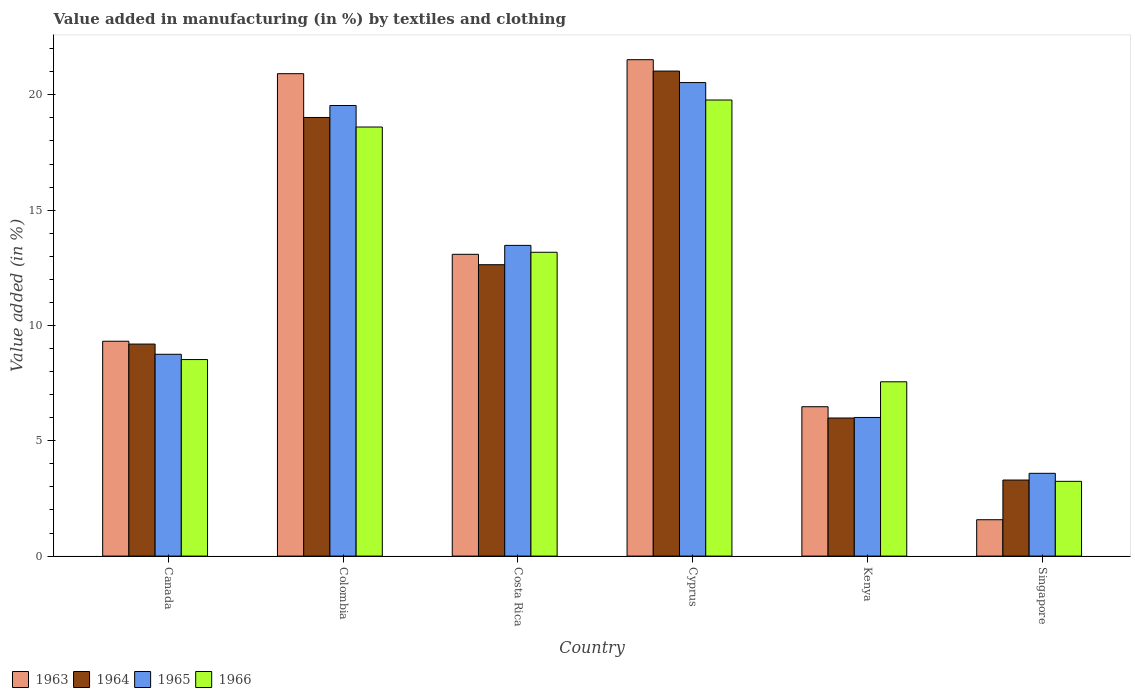How many different coloured bars are there?
Your response must be concise. 4. Are the number of bars per tick equal to the number of legend labels?
Offer a terse response. Yes. Are the number of bars on each tick of the X-axis equal?
Your answer should be compact. Yes. How many bars are there on the 3rd tick from the left?
Provide a short and direct response. 4. What is the label of the 5th group of bars from the left?
Your answer should be very brief. Kenya. What is the percentage of value added in manufacturing by textiles and clothing in 1966 in Canada?
Keep it short and to the point. 8.52. Across all countries, what is the maximum percentage of value added in manufacturing by textiles and clothing in 1965?
Your response must be concise. 20.53. Across all countries, what is the minimum percentage of value added in manufacturing by textiles and clothing in 1964?
Offer a very short reply. 3.3. In which country was the percentage of value added in manufacturing by textiles and clothing in 1965 maximum?
Your response must be concise. Cyprus. In which country was the percentage of value added in manufacturing by textiles and clothing in 1964 minimum?
Your answer should be very brief. Singapore. What is the total percentage of value added in manufacturing by textiles and clothing in 1966 in the graph?
Your answer should be very brief. 70.87. What is the difference between the percentage of value added in manufacturing by textiles and clothing in 1963 in Colombia and that in Singapore?
Your answer should be very brief. 19.34. What is the difference between the percentage of value added in manufacturing by textiles and clothing in 1965 in Canada and the percentage of value added in manufacturing by textiles and clothing in 1964 in Colombia?
Keep it short and to the point. -10.27. What is the average percentage of value added in manufacturing by textiles and clothing in 1963 per country?
Your response must be concise. 12.15. What is the difference between the percentage of value added in manufacturing by textiles and clothing of/in 1963 and percentage of value added in manufacturing by textiles and clothing of/in 1966 in Colombia?
Provide a succinct answer. 2.31. What is the ratio of the percentage of value added in manufacturing by textiles and clothing in 1965 in Costa Rica to that in Kenya?
Make the answer very short. 2.24. Is the difference between the percentage of value added in manufacturing by textiles and clothing in 1963 in Cyprus and Singapore greater than the difference between the percentage of value added in manufacturing by textiles and clothing in 1966 in Cyprus and Singapore?
Your response must be concise. Yes. What is the difference between the highest and the second highest percentage of value added in manufacturing by textiles and clothing in 1963?
Provide a succinct answer. -7.83. What is the difference between the highest and the lowest percentage of value added in manufacturing by textiles and clothing in 1964?
Make the answer very short. 17.73. In how many countries, is the percentage of value added in manufacturing by textiles and clothing in 1966 greater than the average percentage of value added in manufacturing by textiles and clothing in 1966 taken over all countries?
Provide a succinct answer. 3. Is it the case that in every country, the sum of the percentage of value added in manufacturing by textiles and clothing in 1963 and percentage of value added in manufacturing by textiles and clothing in 1964 is greater than the sum of percentage of value added in manufacturing by textiles and clothing in 1966 and percentage of value added in manufacturing by textiles and clothing in 1965?
Provide a succinct answer. No. What does the 4th bar from the left in Kenya represents?
Offer a very short reply. 1966. How many bars are there?
Provide a short and direct response. 24. What is the difference between two consecutive major ticks on the Y-axis?
Keep it short and to the point. 5. Does the graph contain grids?
Your response must be concise. No. What is the title of the graph?
Your answer should be compact. Value added in manufacturing (in %) by textiles and clothing. Does "1984" appear as one of the legend labels in the graph?
Your answer should be very brief. No. What is the label or title of the X-axis?
Your response must be concise. Country. What is the label or title of the Y-axis?
Provide a short and direct response. Value added (in %). What is the Value added (in %) of 1963 in Canada?
Give a very brief answer. 9.32. What is the Value added (in %) of 1964 in Canada?
Provide a short and direct response. 9.19. What is the Value added (in %) in 1965 in Canada?
Offer a very short reply. 8.75. What is the Value added (in %) in 1966 in Canada?
Your answer should be very brief. 8.52. What is the Value added (in %) in 1963 in Colombia?
Provide a short and direct response. 20.92. What is the Value added (in %) in 1964 in Colombia?
Your response must be concise. 19.02. What is the Value added (in %) of 1965 in Colombia?
Your answer should be compact. 19.54. What is the Value added (in %) of 1966 in Colombia?
Your answer should be compact. 18.6. What is the Value added (in %) of 1963 in Costa Rica?
Keep it short and to the point. 13.08. What is the Value added (in %) in 1964 in Costa Rica?
Provide a succinct answer. 12.63. What is the Value added (in %) in 1965 in Costa Rica?
Your response must be concise. 13.47. What is the Value added (in %) of 1966 in Costa Rica?
Your response must be concise. 13.17. What is the Value added (in %) in 1963 in Cyprus?
Make the answer very short. 21.52. What is the Value added (in %) in 1964 in Cyprus?
Your answer should be very brief. 21.03. What is the Value added (in %) of 1965 in Cyprus?
Offer a very short reply. 20.53. What is the Value added (in %) in 1966 in Cyprus?
Provide a short and direct response. 19.78. What is the Value added (in %) of 1963 in Kenya?
Provide a succinct answer. 6.48. What is the Value added (in %) of 1964 in Kenya?
Your answer should be very brief. 5.99. What is the Value added (in %) of 1965 in Kenya?
Give a very brief answer. 6.01. What is the Value added (in %) of 1966 in Kenya?
Provide a short and direct response. 7.56. What is the Value added (in %) of 1963 in Singapore?
Give a very brief answer. 1.58. What is the Value added (in %) in 1964 in Singapore?
Your response must be concise. 3.3. What is the Value added (in %) in 1965 in Singapore?
Make the answer very short. 3.59. What is the Value added (in %) in 1966 in Singapore?
Provide a succinct answer. 3.24. Across all countries, what is the maximum Value added (in %) in 1963?
Provide a succinct answer. 21.52. Across all countries, what is the maximum Value added (in %) in 1964?
Offer a terse response. 21.03. Across all countries, what is the maximum Value added (in %) of 1965?
Provide a short and direct response. 20.53. Across all countries, what is the maximum Value added (in %) in 1966?
Provide a short and direct response. 19.78. Across all countries, what is the minimum Value added (in %) of 1963?
Your answer should be very brief. 1.58. Across all countries, what is the minimum Value added (in %) in 1964?
Your answer should be compact. 3.3. Across all countries, what is the minimum Value added (in %) of 1965?
Offer a terse response. 3.59. Across all countries, what is the minimum Value added (in %) in 1966?
Your response must be concise. 3.24. What is the total Value added (in %) of 1963 in the graph?
Provide a short and direct response. 72.9. What is the total Value added (in %) in 1964 in the graph?
Your response must be concise. 71.16. What is the total Value added (in %) of 1965 in the graph?
Provide a succinct answer. 71.89. What is the total Value added (in %) in 1966 in the graph?
Make the answer very short. 70.87. What is the difference between the Value added (in %) in 1963 in Canada and that in Colombia?
Provide a succinct answer. -11.6. What is the difference between the Value added (in %) of 1964 in Canada and that in Colombia?
Provide a short and direct response. -9.82. What is the difference between the Value added (in %) in 1965 in Canada and that in Colombia?
Offer a terse response. -10.79. What is the difference between the Value added (in %) of 1966 in Canada and that in Colombia?
Your response must be concise. -10.08. What is the difference between the Value added (in %) in 1963 in Canada and that in Costa Rica?
Provide a succinct answer. -3.77. What is the difference between the Value added (in %) in 1964 in Canada and that in Costa Rica?
Keep it short and to the point. -3.44. What is the difference between the Value added (in %) in 1965 in Canada and that in Costa Rica?
Your response must be concise. -4.72. What is the difference between the Value added (in %) of 1966 in Canada and that in Costa Rica?
Provide a short and direct response. -4.65. What is the difference between the Value added (in %) in 1963 in Canada and that in Cyprus?
Offer a very short reply. -12.21. What is the difference between the Value added (in %) in 1964 in Canada and that in Cyprus?
Give a very brief answer. -11.84. What is the difference between the Value added (in %) of 1965 in Canada and that in Cyprus?
Ensure brevity in your answer.  -11.78. What is the difference between the Value added (in %) of 1966 in Canada and that in Cyprus?
Your answer should be very brief. -11.25. What is the difference between the Value added (in %) of 1963 in Canada and that in Kenya?
Offer a terse response. 2.84. What is the difference between the Value added (in %) in 1964 in Canada and that in Kenya?
Provide a short and direct response. 3.21. What is the difference between the Value added (in %) in 1965 in Canada and that in Kenya?
Give a very brief answer. 2.74. What is the difference between the Value added (in %) of 1966 in Canada and that in Kenya?
Make the answer very short. 0.96. What is the difference between the Value added (in %) in 1963 in Canada and that in Singapore?
Provide a succinct answer. 7.74. What is the difference between the Value added (in %) of 1964 in Canada and that in Singapore?
Your answer should be very brief. 5.9. What is the difference between the Value added (in %) in 1965 in Canada and that in Singapore?
Your answer should be very brief. 5.16. What is the difference between the Value added (in %) in 1966 in Canada and that in Singapore?
Provide a short and direct response. 5.28. What is the difference between the Value added (in %) in 1963 in Colombia and that in Costa Rica?
Your answer should be compact. 7.83. What is the difference between the Value added (in %) in 1964 in Colombia and that in Costa Rica?
Provide a succinct answer. 6.38. What is the difference between the Value added (in %) of 1965 in Colombia and that in Costa Rica?
Your answer should be compact. 6.06. What is the difference between the Value added (in %) of 1966 in Colombia and that in Costa Rica?
Provide a short and direct response. 5.43. What is the difference between the Value added (in %) of 1963 in Colombia and that in Cyprus?
Keep it short and to the point. -0.61. What is the difference between the Value added (in %) in 1964 in Colombia and that in Cyprus?
Give a very brief answer. -2.01. What is the difference between the Value added (in %) in 1965 in Colombia and that in Cyprus?
Offer a very short reply. -0.99. What is the difference between the Value added (in %) of 1966 in Colombia and that in Cyprus?
Your answer should be very brief. -1.17. What is the difference between the Value added (in %) of 1963 in Colombia and that in Kenya?
Keep it short and to the point. 14.44. What is the difference between the Value added (in %) of 1964 in Colombia and that in Kenya?
Ensure brevity in your answer.  13.03. What is the difference between the Value added (in %) in 1965 in Colombia and that in Kenya?
Your response must be concise. 13.53. What is the difference between the Value added (in %) in 1966 in Colombia and that in Kenya?
Your answer should be very brief. 11.05. What is the difference between the Value added (in %) of 1963 in Colombia and that in Singapore?
Your answer should be very brief. 19.34. What is the difference between the Value added (in %) of 1964 in Colombia and that in Singapore?
Your answer should be compact. 15.72. What is the difference between the Value added (in %) of 1965 in Colombia and that in Singapore?
Your response must be concise. 15.95. What is the difference between the Value added (in %) in 1966 in Colombia and that in Singapore?
Give a very brief answer. 15.36. What is the difference between the Value added (in %) in 1963 in Costa Rica and that in Cyprus?
Keep it short and to the point. -8.44. What is the difference between the Value added (in %) of 1964 in Costa Rica and that in Cyprus?
Keep it short and to the point. -8.4. What is the difference between the Value added (in %) of 1965 in Costa Rica and that in Cyprus?
Give a very brief answer. -7.06. What is the difference between the Value added (in %) in 1966 in Costa Rica and that in Cyprus?
Provide a short and direct response. -6.6. What is the difference between the Value added (in %) of 1963 in Costa Rica and that in Kenya?
Your answer should be compact. 6.61. What is the difference between the Value added (in %) in 1964 in Costa Rica and that in Kenya?
Give a very brief answer. 6.65. What is the difference between the Value added (in %) in 1965 in Costa Rica and that in Kenya?
Offer a very short reply. 7.46. What is the difference between the Value added (in %) in 1966 in Costa Rica and that in Kenya?
Provide a short and direct response. 5.62. What is the difference between the Value added (in %) in 1963 in Costa Rica and that in Singapore?
Keep it short and to the point. 11.51. What is the difference between the Value added (in %) of 1964 in Costa Rica and that in Singapore?
Your answer should be compact. 9.34. What is the difference between the Value added (in %) of 1965 in Costa Rica and that in Singapore?
Ensure brevity in your answer.  9.88. What is the difference between the Value added (in %) of 1966 in Costa Rica and that in Singapore?
Provide a succinct answer. 9.93. What is the difference between the Value added (in %) in 1963 in Cyprus and that in Kenya?
Provide a short and direct response. 15.05. What is the difference between the Value added (in %) in 1964 in Cyprus and that in Kenya?
Provide a succinct answer. 15.04. What is the difference between the Value added (in %) in 1965 in Cyprus and that in Kenya?
Provide a short and direct response. 14.52. What is the difference between the Value added (in %) in 1966 in Cyprus and that in Kenya?
Provide a short and direct response. 12.22. What is the difference between the Value added (in %) of 1963 in Cyprus and that in Singapore?
Your answer should be very brief. 19.95. What is the difference between the Value added (in %) of 1964 in Cyprus and that in Singapore?
Make the answer very short. 17.73. What is the difference between the Value added (in %) of 1965 in Cyprus and that in Singapore?
Offer a terse response. 16.94. What is the difference between the Value added (in %) of 1966 in Cyprus and that in Singapore?
Offer a terse response. 16.53. What is the difference between the Value added (in %) of 1963 in Kenya and that in Singapore?
Your answer should be compact. 4.9. What is the difference between the Value added (in %) of 1964 in Kenya and that in Singapore?
Offer a terse response. 2.69. What is the difference between the Value added (in %) of 1965 in Kenya and that in Singapore?
Your answer should be compact. 2.42. What is the difference between the Value added (in %) of 1966 in Kenya and that in Singapore?
Give a very brief answer. 4.32. What is the difference between the Value added (in %) of 1963 in Canada and the Value added (in %) of 1964 in Colombia?
Ensure brevity in your answer.  -9.7. What is the difference between the Value added (in %) of 1963 in Canada and the Value added (in %) of 1965 in Colombia?
Offer a terse response. -10.22. What is the difference between the Value added (in %) of 1963 in Canada and the Value added (in %) of 1966 in Colombia?
Your response must be concise. -9.29. What is the difference between the Value added (in %) of 1964 in Canada and the Value added (in %) of 1965 in Colombia?
Offer a very short reply. -10.34. What is the difference between the Value added (in %) of 1964 in Canada and the Value added (in %) of 1966 in Colombia?
Provide a short and direct response. -9.41. What is the difference between the Value added (in %) in 1965 in Canada and the Value added (in %) in 1966 in Colombia?
Your response must be concise. -9.85. What is the difference between the Value added (in %) of 1963 in Canada and the Value added (in %) of 1964 in Costa Rica?
Make the answer very short. -3.32. What is the difference between the Value added (in %) in 1963 in Canada and the Value added (in %) in 1965 in Costa Rica?
Keep it short and to the point. -4.16. What is the difference between the Value added (in %) in 1963 in Canada and the Value added (in %) in 1966 in Costa Rica?
Make the answer very short. -3.86. What is the difference between the Value added (in %) in 1964 in Canada and the Value added (in %) in 1965 in Costa Rica?
Your answer should be very brief. -4.28. What is the difference between the Value added (in %) of 1964 in Canada and the Value added (in %) of 1966 in Costa Rica?
Ensure brevity in your answer.  -3.98. What is the difference between the Value added (in %) of 1965 in Canada and the Value added (in %) of 1966 in Costa Rica?
Provide a succinct answer. -4.42. What is the difference between the Value added (in %) of 1963 in Canada and the Value added (in %) of 1964 in Cyprus?
Your response must be concise. -11.71. What is the difference between the Value added (in %) in 1963 in Canada and the Value added (in %) in 1965 in Cyprus?
Offer a terse response. -11.21. What is the difference between the Value added (in %) of 1963 in Canada and the Value added (in %) of 1966 in Cyprus?
Give a very brief answer. -10.46. What is the difference between the Value added (in %) in 1964 in Canada and the Value added (in %) in 1965 in Cyprus?
Offer a terse response. -11.34. What is the difference between the Value added (in %) in 1964 in Canada and the Value added (in %) in 1966 in Cyprus?
Offer a terse response. -10.58. What is the difference between the Value added (in %) in 1965 in Canada and the Value added (in %) in 1966 in Cyprus?
Your answer should be very brief. -11.02. What is the difference between the Value added (in %) of 1963 in Canada and the Value added (in %) of 1964 in Kenya?
Give a very brief answer. 3.33. What is the difference between the Value added (in %) in 1963 in Canada and the Value added (in %) in 1965 in Kenya?
Offer a terse response. 3.31. What is the difference between the Value added (in %) in 1963 in Canada and the Value added (in %) in 1966 in Kenya?
Your response must be concise. 1.76. What is the difference between the Value added (in %) in 1964 in Canada and the Value added (in %) in 1965 in Kenya?
Ensure brevity in your answer.  3.18. What is the difference between the Value added (in %) of 1964 in Canada and the Value added (in %) of 1966 in Kenya?
Your answer should be very brief. 1.64. What is the difference between the Value added (in %) in 1965 in Canada and the Value added (in %) in 1966 in Kenya?
Make the answer very short. 1.19. What is the difference between the Value added (in %) in 1963 in Canada and the Value added (in %) in 1964 in Singapore?
Provide a short and direct response. 6.02. What is the difference between the Value added (in %) of 1963 in Canada and the Value added (in %) of 1965 in Singapore?
Your answer should be compact. 5.73. What is the difference between the Value added (in %) of 1963 in Canada and the Value added (in %) of 1966 in Singapore?
Make the answer very short. 6.08. What is the difference between the Value added (in %) of 1964 in Canada and the Value added (in %) of 1965 in Singapore?
Give a very brief answer. 5.6. What is the difference between the Value added (in %) in 1964 in Canada and the Value added (in %) in 1966 in Singapore?
Offer a terse response. 5.95. What is the difference between the Value added (in %) of 1965 in Canada and the Value added (in %) of 1966 in Singapore?
Give a very brief answer. 5.51. What is the difference between the Value added (in %) in 1963 in Colombia and the Value added (in %) in 1964 in Costa Rica?
Provide a succinct answer. 8.28. What is the difference between the Value added (in %) in 1963 in Colombia and the Value added (in %) in 1965 in Costa Rica?
Offer a terse response. 7.44. What is the difference between the Value added (in %) in 1963 in Colombia and the Value added (in %) in 1966 in Costa Rica?
Your answer should be compact. 7.74. What is the difference between the Value added (in %) in 1964 in Colombia and the Value added (in %) in 1965 in Costa Rica?
Your response must be concise. 5.55. What is the difference between the Value added (in %) of 1964 in Colombia and the Value added (in %) of 1966 in Costa Rica?
Your response must be concise. 5.84. What is the difference between the Value added (in %) of 1965 in Colombia and the Value added (in %) of 1966 in Costa Rica?
Provide a short and direct response. 6.36. What is the difference between the Value added (in %) in 1963 in Colombia and the Value added (in %) in 1964 in Cyprus?
Your response must be concise. -0.11. What is the difference between the Value added (in %) in 1963 in Colombia and the Value added (in %) in 1965 in Cyprus?
Offer a very short reply. 0.39. What is the difference between the Value added (in %) in 1963 in Colombia and the Value added (in %) in 1966 in Cyprus?
Provide a succinct answer. 1.14. What is the difference between the Value added (in %) of 1964 in Colombia and the Value added (in %) of 1965 in Cyprus?
Provide a succinct answer. -1.51. What is the difference between the Value added (in %) of 1964 in Colombia and the Value added (in %) of 1966 in Cyprus?
Provide a succinct answer. -0.76. What is the difference between the Value added (in %) in 1965 in Colombia and the Value added (in %) in 1966 in Cyprus?
Give a very brief answer. -0.24. What is the difference between the Value added (in %) in 1963 in Colombia and the Value added (in %) in 1964 in Kenya?
Your answer should be very brief. 14.93. What is the difference between the Value added (in %) in 1963 in Colombia and the Value added (in %) in 1965 in Kenya?
Ensure brevity in your answer.  14.91. What is the difference between the Value added (in %) in 1963 in Colombia and the Value added (in %) in 1966 in Kenya?
Your response must be concise. 13.36. What is the difference between the Value added (in %) in 1964 in Colombia and the Value added (in %) in 1965 in Kenya?
Give a very brief answer. 13.01. What is the difference between the Value added (in %) in 1964 in Colombia and the Value added (in %) in 1966 in Kenya?
Provide a succinct answer. 11.46. What is the difference between the Value added (in %) of 1965 in Colombia and the Value added (in %) of 1966 in Kenya?
Provide a short and direct response. 11.98. What is the difference between the Value added (in %) of 1963 in Colombia and the Value added (in %) of 1964 in Singapore?
Offer a terse response. 17.62. What is the difference between the Value added (in %) in 1963 in Colombia and the Value added (in %) in 1965 in Singapore?
Offer a terse response. 17.33. What is the difference between the Value added (in %) in 1963 in Colombia and the Value added (in %) in 1966 in Singapore?
Offer a very short reply. 17.68. What is the difference between the Value added (in %) of 1964 in Colombia and the Value added (in %) of 1965 in Singapore?
Ensure brevity in your answer.  15.43. What is the difference between the Value added (in %) in 1964 in Colombia and the Value added (in %) in 1966 in Singapore?
Provide a succinct answer. 15.78. What is the difference between the Value added (in %) in 1965 in Colombia and the Value added (in %) in 1966 in Singapore?
Provide a short and direct response. 16.3. What is the difference between the Value added (in %) in 1963 in Costa Rica and the Value added (in %) in 1964 in Cyprus?
Offer a very short reply. -7.95. What is the difference between the Value added (in %) of 1963 in Costa Rica and the Value added (in %) of 1965 in Cyprus?
Provide a short and direct response. -7.45. What is the difference between the Value added (in %) in 1963 in Costa Rica and the Value added (in %) in 1966 in Cyprus?
Your answer should be very brief. -6.69. What is the difference between the Value added (in %) of 1964 in Costa Rica and the Value added (in %) of 1965 in Cyprus?
Ensure brevity in your answer.  -7.9. What is the difference between the Value added (in %) of 1964 in Costa Rica and the Value added (in %) of 1966 in Cyprus?
Ensure brevity in your answer.  -7.14. What is the difference between the Value added (in %) in 1965 in Costa Rica and the Value added (in %) in 1966 in Cyprus?
Give a very brief answer. -6.3. What is the difference between the Value added (in %) in 1963 in Costa Rica and the Value added (in %) in 1964 in Kenya?
Provide a short and direct response. 7.1. What is the difference between the Value added (in %) in 1963 in Costa Rica and the Value added (in %) in 1965 in Kenya?
Make the answer very short. 7.07. What is the difference between the Value added (in %) of 1963 in Costa Rica and the Value added (in %) of 1966 in Kenya?
Keep it short and to the point. 5.53. What is the difference between the Value added (in %) in 1964 in Costa Rica and the Value added (in %) in 1965 in Kenya?
Provide a short and direct response. 6.62. What is the difference between the Value added (in %) in 1964 in Costa Rica and the Value added (in %) in 1966 in Kenya?
Your answer should be very brief. 5.08. What is the difference between the Value added (in %) in 1965 in Costa Rica and the Value added (in %) in 1966 in Kenya?
Your response must be concise. 5.91. What is the difference between the Value added (in %) in 1963 in Costa Rica and the Value added (in %) in 1964 in Singapore?
Make the answer very short. 9.79. What is the difference between the Value added (in %) of 1963 in Costa Rica and the Value added (in %) of 1965 in Singapore?
Your answer should be very brief. 9.5. What is the difference between the Value added (in %) of 1963 in Costa Rica and the Value added (in %) of 1966 in Singapore?
Make the answer very short. 9.84. What is the difference between the Value added (in %) in 1964 in Costa Rica and the Value added (in %) in 1965 in Singapore?
Keep it short and to the point. 9.04. What is the difference between the Value added (in %) of 1964 in Costa Rica and the Value added (in %) of 1966 in Singapore?
Provide a short and direct response. 9.39. What is the difference between the Value added (in %) in 1965 in Costa Rica and the Value added (in %) in 1966 in Singapore?
Offer a terse response. 10.23. What is the difference between the Value added (in %) of 1963 in Cyprus and the Value added (in %) of 1964 in Kenya?
Your response must be concise. 15.54. What is the difference between the Value added (in %) in 1963 in Cyprus and the Value added (in %) in 1965 in Kenya?
Offer a terse response. 15.51. What is the difference between the Value added (in %) in 1963 in Cyprus and the Value added (in %) in 1966 in Kenya?
Offer a terse response. 13.97. What is the difference between the Value added (in %) in 1964 in Cyprus and the Value added (in %) in 1965 in Kenya?
Your answer should be compact. 15.02. What is the difference between the Value added (in %) of 1964 in Cyprus and the Value added (in %) of 1966 in Kenya?
Your answer should be compact. 13.47. What is the difference between the Value added (in %) in 1965 in Cyprus and the Value added (in %) in 1966 in Kenya?
Offer a terse response. 12.97. What is the difference between the Value added (in %) of 1963 in Cyprus and the Value added (in %) of 1964 in Singapore?
Make the answer very short. 18.23. What is the difference between the Value added (in %) in 1963 in Cyprus and the Value added (in %) in 1965 in Singapore?
Make the answer very short. 17.93. What is the difference between the Value added (in %) in 1963 in Cyprus and the Value added (in %) in 1966 in Singapore?
Ensure brevity in your answer.  18.28. What is the difference between the Value added (in %) in 1964 in Cyprus and the Value added (in %) in 1965 in Singapore?
Keep it short and to the point. 17.44. What is the difference between the Value added (in %) in 1964 in Cyprus and the Value added (in %) in 1966 in Singapore?
Your answer should be compact. 17.79. What is the difference between the Value added (in %) in 1965 in Cyprus and the Value added (in %) in 1966 in Singapore?
Your response must be concise. 17.29. What is the difference between the Value added (in %) in 1963 in Kenya and the Value added (in %) in 1964 in Singapore?
Your response must be concise. 3.18. What is the difference between the Value added (in %) in 1963 in Kenya and the Value added (in %) in 1965 in Singapore?
Keep it short and to the point. 2.89. What is the difference between the Value added (in %) in 1963 in Kenya and the Value added (in %) in 1966 in Singapore?
Offer a terse response. 3.24. What is the difference between the Value added (in %) of 1964 in Kenya and the Value added (in %) of 1965 in Singapore?
Your answer should be very brief. 2.4. What is the difference between the Value added (in %) in 1964 in Kenya and the Value added (in %) in 1966 in Singapore?
Provide a succinct answer. 2.75. What is the difference between the Value added (in %) of 1965 in Kenya and the Value added (in %) of 1966 in Singapore?
Provide a short and direct response. 2.77. What is the average Value added (in %) of 1963 per country?
Keep it short and to the point. 12.15. What is the average Value added (in %) in 1964 per country?
Provide a short and direct response. 11.86. What is the average Value added (in %) of 1965 per country?
Offer a terse response. 11.98. What is the average Value added (in %) of 1966 per country?
Your response must be concise. 11.81. What is the difference between the Value added (in %) of 1963 and Value added (in %) of 1964 in Canada?
Offer a terse response. 0.12. What is the difference between the Value added (in %) in 1963 and Value added (in %) in 1965 in Canada?
Offer a terse response. 0.57. What is the difference between the Value added (in %) in 1963 and Value added (in %) in 1966 in Canada?
Your answer should be compact. 0.8. What is the difference between the Value added (in %) of 1964 and Value added (in %) of 1965 in Canada?
Your answer should be compact. 0.44. What is the difference between the Value added (in %) in 1964 and Value added (in %) in 1966 in Canada?
Keep it short and to the point. 0.67. What is the difference between the Value added (in %) of 1965 and Value added (in %) of 1966 in Canada?
Provide a succinct answer. 0.23. What is the difference between the Value added (in %) in 1963 and Value added (in %) in 1964 in Colombia?
Ensure brevity in your answer.  1.9. What is the difference between the Value added (in %) of 1963 and Value added (in %) of 1965 in Colombia?
Offer a very short reply. 1.38. What is the difference between the Value added (in %) in 1963 and Value added (in %) in 1966 in Colombia?
Provide a succinct answer. 2.31. What is the difference between the Value added (in %) of 1964 and Value added (in %) of 1965 in Colombia?
Your answer should be very brief. -0.52. What is the difference between the Value added (in %) of 1964 and Value added (in %) of 1966 in Colombia?
Give a very brief answer. 0.41. What is the difference between the Value added (in %) in 1965 and Value added (in %) in 1966 in Colombia?
Keep it short and to the point. 0.93. What is the difference between the Value added (in %) of 1963 and Value added (in %) of 1964 in Costa Rica?
Provide a short and direct response. 0.45. What is the difference between the Value added (in %) in 1963 and Value added (in %) in 1965 in Costa Rica?
Keep it short and to the point. -0.39. What is the difference between the Value added (in %) of 1963 and Value added (in %) of 1966 in Costa Rica?
Your answer should be compact. -0.09. What is the difference between the Value added (in %) of 1964 and Value added (in %) of 1965 in Costa Rica?
Offer a very short reply. -0.84. What is the difference between the Value added (in %) in 1964 and Value added (in %) in 1966 in Costa Rica?
Offer a terse response. -0.54. What is the difference between the Value added (in %) of 1965 and Value added (in %) of 1966 in Costa Rica?
Give a very brief answer. 0.3. What is the difference between the Value added (in %) in 1963 and Value added (in %) in 1964 in Cyprus?
Make the answer very short. 0.49. What is the difference between the Value added (in %) in 1963 and Value added (in %) in 1965 in Cyprus?
Your response must be concise. 0.99. What is the difference between the Value added (in %) in 1963 and Value added (in %) in 1966 in Cyprus?
Provide a succinct answer. 1.75. What is the difference between the Value added (in %) of 1964 and Value added (in %) of 1965 in Cyprus?
Your answer should be compact. 0.5. What is the difference between the Value added (in %) of 1964 and Value added (in %) of 1966 in Cyprus?
Your response must be concise. 1.25. What is the difference between the Value added (in %) of 1965 and Value added (in %) of 1966 in Cyprus?
Ensure brevity in your answer.  0.76. What is the difference between the Value added (in %) in 1963 and Value added (in %) in 1964 in Kenya?
Your response must be concise. 0.49. What is the difference between the Value added (in %) of 1963 and Value added (in %) of 1965 in Kenya?
Ensure brevity in your answer.  0.47. What is the difference between the Value added (in %) of 1963 and Value added (in %) of 1966 in Kenya?
Offer a terse response. -1.08. What is the difference between the Value added (in %) of 1964 and Value added (in %) of 1965 in Kenya?
Offer a very short reply. -0.02. What is the difference between the Value added (in %) in 1964 and Value added (in %) in 1966 in Kenya?
Your answer should be compact. -1.57. What is the difference between the Value added (in %) in 1965 and Value added (in %) in 1966 in Kenya?
Ensure brevity in your answer.  -1.55. What is the difference between the Value added (in %) in 1963 and Value added (in %) in 1964 in Singapore?
Your response must be concise. -1.72. What is the difference between the Value added (in %) of 1963 and Value added (in %) of 1965 in Singapore?
Offer a very short reply. -2.01. What is the difference between the Value added (in %) in 1963 and Value added (in %) in 1966 in Singapore?
Your answer should be compact. -1.66. What is the difference between the Value added (in %) of 1964 and Value added (in %) of 1965 in Singapore?
Give a very brief answer. -0.29. What is the difference between the Value added (in %) in 1964 and Value added (in %) in 1966 in Singapore?
Make the answer very short. 0.06. What is the difference between the Value added (in %) of 1965 and Value added (in %) of 1966 in Singapore?
Make the answer very short. 0.35. What is the ratio of the Value added (in %) in 1963 in Canada to that in Colombia?
Keep it short and to the point. 0.45. What is the ratio of the Value added (in %) in 1964 in Canada to that in Colombia?
Make the answer very short. 0.48. What is the ratio of the Value added (in %) in 1965 in Canada to that in Colombia?
Your response must be concise. 0.45. What is the ratio of the Value added (in %) of 1966 in Canada to that in Colombia?
Your response must be concise. 0.46. What is the ratio of the Value added (in %) in 1963 in Canada to that in Costa Rica?
Offer a very short reply. 0.71. What is the ratio of the Value added (in %) in 1964 in Canada to that in Costa Rica?
Keep it short and to the point. 0.73. What is the ratio of the Value added (in %) of 1965 in Canada to that in Costa Rica?
Keep it short and to the point. 0.65. What is the ratio of the Value added (in %) of 1966 in Canada to that in Costa Rica?
Provide a short and direct response. 0.65. What is the ratio of the Value added (in %) in 1963 in Canada to that in Cyprus?
Provide a succinct answer. 0.43. What is the ratio of the Value added (in %) of 1964 in Canada to that in Cyprus?
Your answer should be very brief. 0.44. What is the ratio of the Value added (in %) of 1965 in Canada to that in Cyprus?
Give a very brief answer. 0.43. What is the ratio of the Value added (in %) in 1966 in Canada to that in Cyprus?
Offer a terse response. 0.43. What is the ratio of the Value added (in %) in 1963 in Canada to that in Kenya?
Provide a succinct answer. 1.44. What is the ratio of the Value added (in %) in 1964 in Canada to that in Kenya?
Your response must be concise. 1.54. What is the ratio of the Value added (in %) of 1965 in Canada to that in Kenya?
Keep it short and to the point. 1.46. What is the ratio of the Value added (in %) in 1966 in Canada to that in Kenya?
Ensure brevity in your answer.  1.13. What is the ratio of the Value added (in %) of 1963 in Canada to that in Singapore?
Give a very brief answer. 5.91. What is the ratio of the Value added (in %) in 1964 in Canada to that in Singapore?
Keep it short and to the point. 2.79. What is the ratio of the Value added (in %) of 1965 in Canada to that in Singapore?
Keep it short and to the point. 2.44. What is the ratio of the Value added (in %) in 1966 in Canada to that in Singapore?
Provide a short and direct response. 2.63. What is the ratio of the Value added (in %) of 1963 in Colombia to that in Costa Rica?
Your response must be concise. 1.6. What is the ratio of the Value added (in %) of 1964 in Colombia to that in Costa Rica?
Your answer should be compact. 1.51. What is the ratio of the Value added (in %) in 1965 in Colombia to that in Costa Rica?
Provide a succinct answer. 1.45. What is the ratio of the Value added (in %) in 1966 in Colombia to that in Costa Rica?
Your response must be concise. 1.41. What is the ratio of the Value added (in %) of 1963 in Colombia to that in Cyprus?
Offer a very short reply. 0.97. What is the ratio of the Value added (in %) in 1964 in Colombia to that in Cyprus?
Your answer should be very brief. 0.9. What is the ratio of the Value added (in %) in 1965 in Colombia to that in Cyprus?
Offer a very short reply. 0.95. What is the ratio of the Value added (in %) of 1966 in Colombia to that in Cyprus?
Your answer should be compact. 0.94. What is the ratio of the Value added (in %) in 1963 in Colombia to that in Kenya?
Keep it short and to the point. 3.23. What is the ratio of the Value added (in %) of 1964 in Colombia to that in Kenya?
Keep it short and to the point. 3.18. What is the ratio of the Value added (in %) of 1965 in Colombia to that in Kenya?
Your response must be concise. 3.25. What is the ratio of the Value added (in %) of 1966 in Colombia to that in Kenya?
Your response must be concise. 2.46. What is the ratio of the Value added (in %) of 1963 in Colombia to that in Singapore?
Your answer should be very brief. 13.26. What is the ratio of the Value added (in %) of 1964 in Colombia to that in Singapore?
Your answer should be compact. 5.77. What is the ratio of the Value added (in %) in 1965 in Colombia to that in Singapore?
Provide a succinct answer. 5.44. What is the ratio of the Value added (in %) of 1966 in Colombia to that in Singapore?
Your answer should be compact. 5.74. What is the ratio of the Value added (in %) in 1963 in Costa Rica to that in Cyprus?
Provide a succinct answer. 0.61. What is the ratio of the Value added (in %) of 1964 in Costa Rica to that in Cyprus?
Offer a very short reply. 0.6. What is the ratio of the Value added (in %) of 1965 in Costa Rica to that in Cyprus?
Offer a very short reply. 0.66. What is the ratio of the Value added (in %) in 1966 in Costa Rica to that in Cyprus?
Offer a terse response. 0.67. What is the ratio of the Value added (in %) in 1963 in Costa Rica to that in Kenya?
Give a very brief answer. 2.02. What is the ratio of the Value added (in %) in 1964 in Costa Rica to that in Kenya?
Keep it short and to the point. 2.11. What is the ratio of the Value added (in %) in 1965 in Costa Rica to that in Kenya?
Provide a short and direct response. 2.24. What is the ratio of the Value added (in %) in 1966 in Costa Rica to that in Kenya?
Make the answer very short. 1.74. What is the ratio of the Value added (in %) of 1963 in Costa Rica to that in Singapore?
Ensure brevity in your answer.  8.3. What is the ratio of the Value added (in %) of 1964 in Costa Rica to that in Singapore?
Offer a very short reply. 3.83. What is the ratio of the Value added (in %) of 1965 in Costa Rica to that in Singapore?
Offer a very short reply. 3.75. What is the ratio of the Value added (in %) of 1966 in Costa Rica to that in Singapore?
Your answer should be compact. 4.06. What is the ratio of the Value added (in %) in 1963 in Cyprus to that in Kenya?
Ensure brevity in your answer.  3.32. What is the ratio of the Value added (in %) in 1964 in Cyprus to that in Kenya?
Provide a short and direct response. 3.51. What is the ratio of the Value added (in %) of 1965 in Cyprus to that in Kenya?
Keep it short and to the point. 3.42. What is the ratio of the Value added (in %) in 1966 in Cyprus to that in Kenya?
Offer a very short reply. 2.62. What is the ratio of the Value added (in %) of 1963 in Cyprus to that in Singapore?
Offer a very short reply. 13.65. What is the ratio of the Value added (in %) in 1964 in Cyprus to that in Singapore?
Your response must be concise. 6.38. What is the ratio of the Value added (in %) of 1965 in Cyprus to that in Singapore?
Make the answer very short. 5.72. What is the ratio of the Value added (in %) of 1966 in Cyprus to that in Singapore?
Give a very brief answer. 6.1. What is the ratio of the Value added (in %) of 1963 in Kenya to that in Singapore?
Make the answer very short. 4.11. What is the ratio of the Value added (in %) in 1964 in Kenya to that in Singapore?
Offer a very short reply. 1.82. What is the ratio of the Value added (in %) of 1965 in Kenya to that in Singapore?
Ensure brevity in your answer.  1.67. What is the ratio of the Value added (in %) of 1966 in Kenya to that in Singapore?
Provide a short and direct response. 2.33. What is the difference between the highest and the second highest Value added (in %) in 1963?
Keep it short and to the point. 0.61. What is the difference between the highest and the second highest Value added (in %) of 1964?
Keep it short and to the point. 2.01. What is the difference between the highest and the second highest Value added (in %) of 1966?
Your answer should be compact. 1.17. What is the difference between the highest and the lowest Value added (in %) of 1963?
Offer a very short reply. 19.95. What is the difference between the highest and the lowest Value added (in %) of 1964?
Your response must be concise. 17.73. What is the difference between the highest and the lowest Value added (in %) of 1965?
Offer a terse response. 16.94. What is the difference between the highest and the lowest Value added (in %) of 1966?
Your response must be concise. 16.53. 